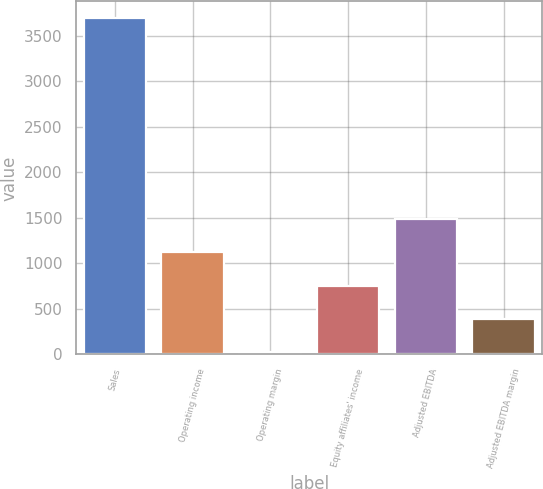<chart> <loc_0><loc_0><loc_500><loc_500><bar_chart><fcel>Sales<fcel>Operating income<fcel>Operating margin<fcel>Equity affiliates' income<fcel>Adjusted EBITDA<fcel>Adjusted EBITDA margin<nl><fcel>3693.9<fcel>1123.5<fcel>21.9<fcel>756.3<fcel>1490.7<fcel>389.1<nl></chart> 